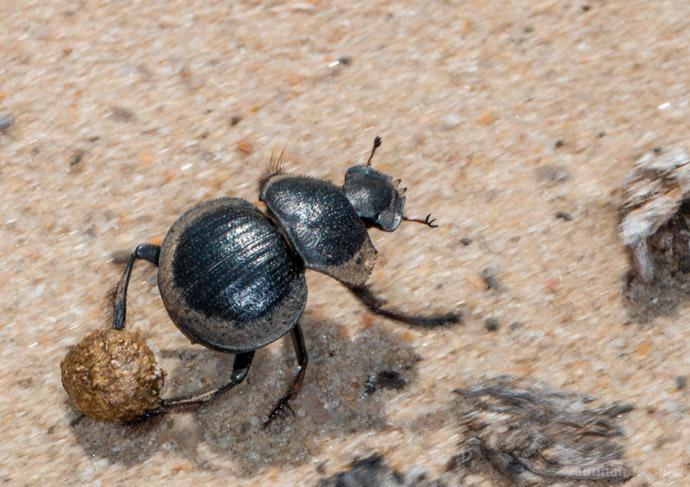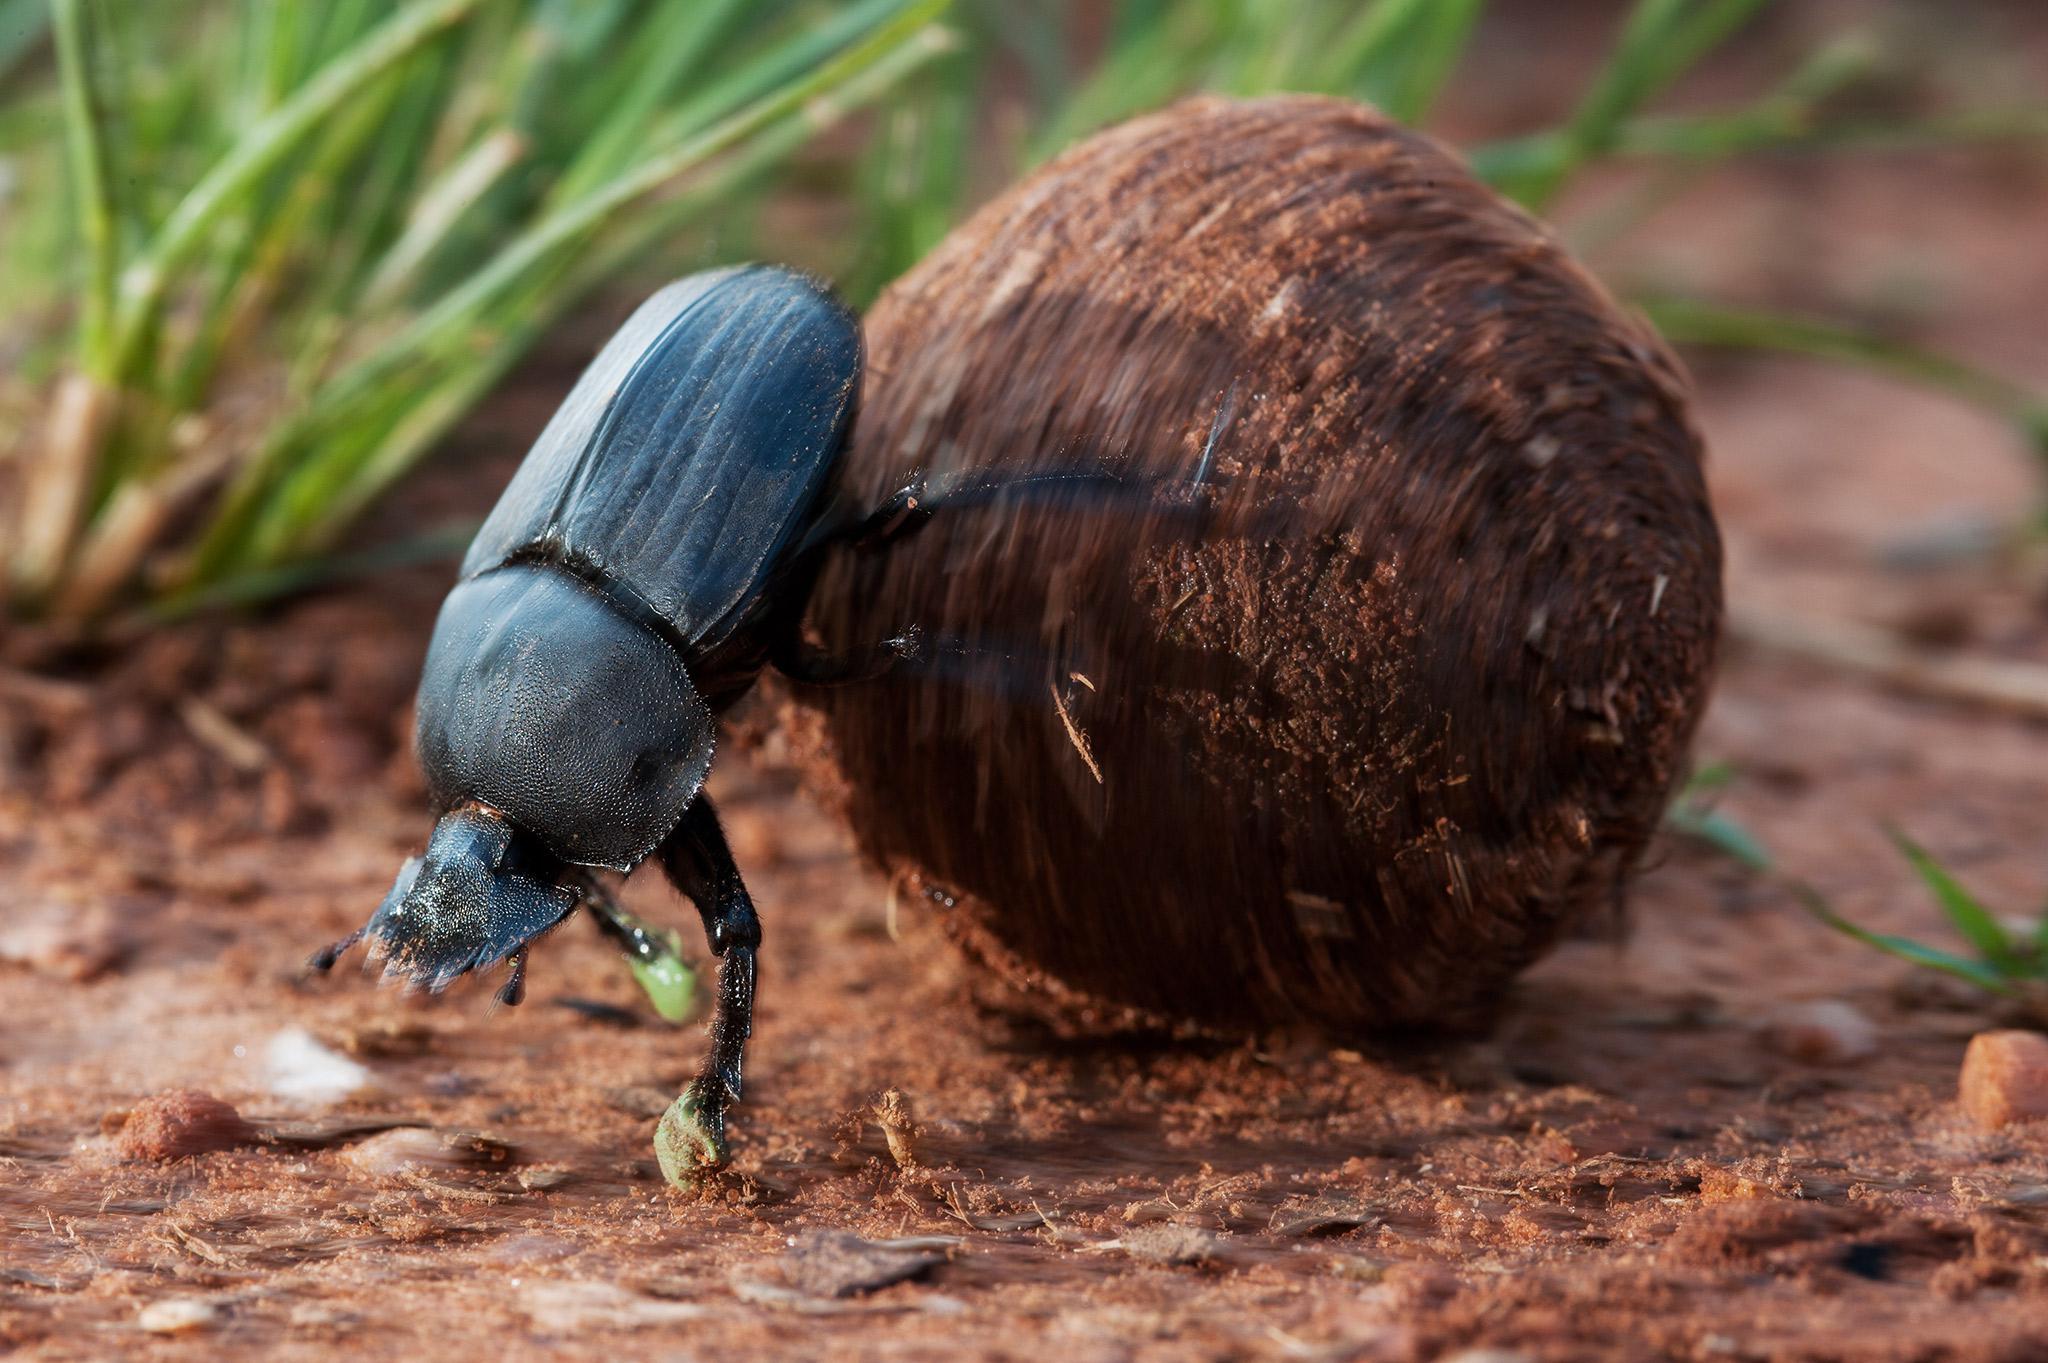The first image is the image on the left, the second image is the image on the right. Assess this claim about the two images: "Each image includes a beetle with a dungball that is bigger than the beetle.". Correct or not? Answer yes or no. No. The first image is the image on the left, the second image is the image on the right. Examine the images to the left and right. Is the description "There are two beetles near one clod of dirt in one of the images." accurate? Answer yes or no. No. 